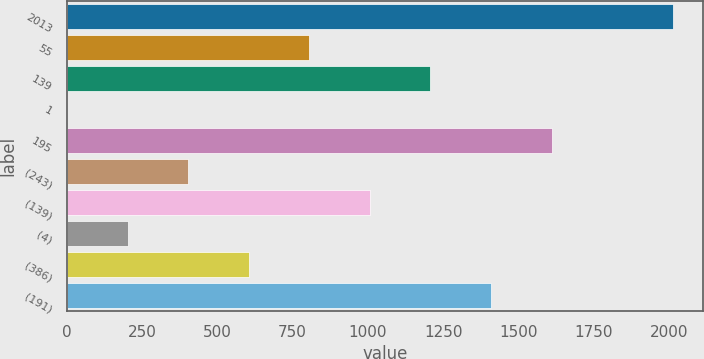<chart> <loc_0><loc_0><loc_500><loc_500><bar_chart><fcel>2013<fcel>55<fcel>139<fcel>1<fcel>195<fcel>(243)<fcel>(139)<fcel>(4)<fcel>(386)<fcel>(191)<nl><fcel>2012<fcel>805.4<fcel>1207.6<fcel>1<fcel>1609.8<fcel>403.2<fcel>1006.5<fcel>202.1<fcel>604.3<fcel>1408.7<nl></chart> 